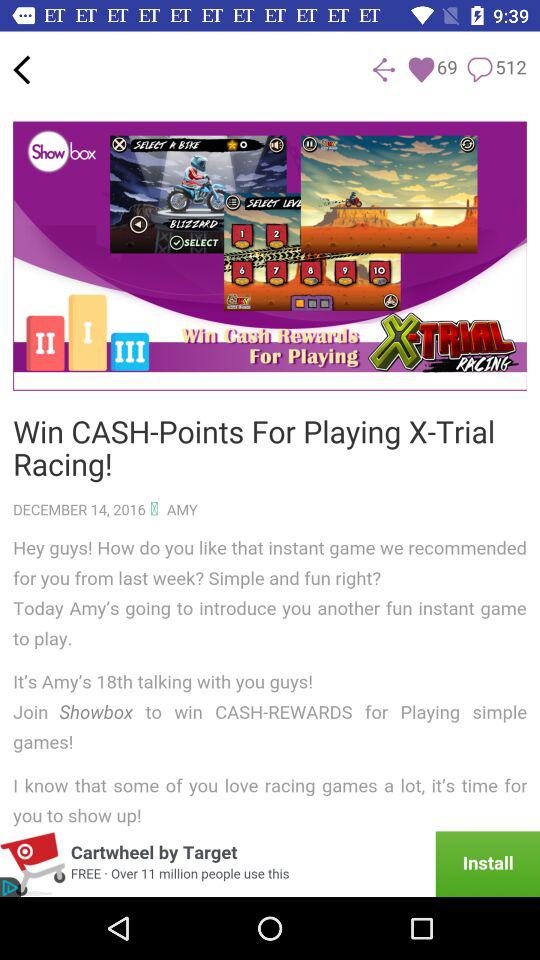How many text elements are there in the top right corner?
Answer the question using a single word or phrase. 2 